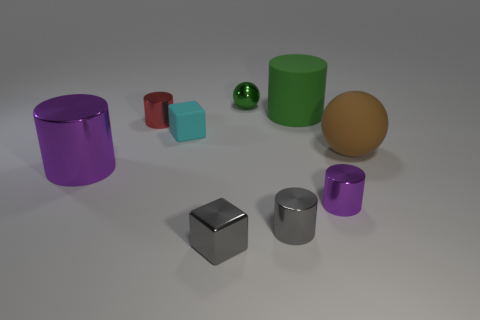What shape is the purple object to the right of the purple metal cylinder that is to the left of the small purple cylinder?
Offer a very short reply. Cylinder. There is a shiny cube; what number of small cyan rubber cubes are on the right side of it?
Your answer should be very brief. 0. Is the brown thing made of the same material as the tiny cylinder to the left of the tiny cyan thing?
Your response must be concise. No. Is there a matte ball of the same size as the green cylinder?
Make the answer very short. Yes. Is the number of green rubber things that are behind the tiny green ball the same as the number of big blue metal objects?
Your response must be concise. Yes. What size is the cyan block?
Provide a succinct answer. Small. How many green objects are in front of the sphere in front of the small green shiny thing?
Make the answer very short. 0. What shape is the small thing that is both in front of the cyan rubber thing and left of the small metallic sphere?
Provide a short and direct response. Cube. What number of large things have the same color as the small ball?
Provide a short and direct response. 1. There is a tiny cube that is in front of the purple metallic thing left of the tiny green shiny ball; are there any blocks that are to the left of it?
Keep it short and to the point. Yes. 